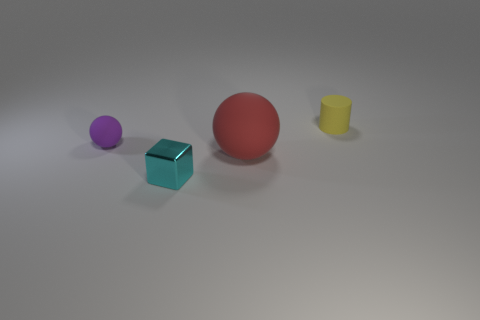Add 3 large blue shiny objects. How many objects exist? 7 Subtract all red spheres. How many spheres are left? 1 Subtract all cylinders. How many objects are left? 3 Add 3 tiny cylinders. How many tiny cylinders exist? 4 Subtract 0 blue spheres. How many objects are left? 4 Subtract all brown cylinders. Subtract all gray balls. How many cylinders are left? 1 Subtract all red matte objects. Subtract all gray rubber cubes. How many objects are left? 3 Add 1 big rubber objects. How many big rubber objects are left? 2 